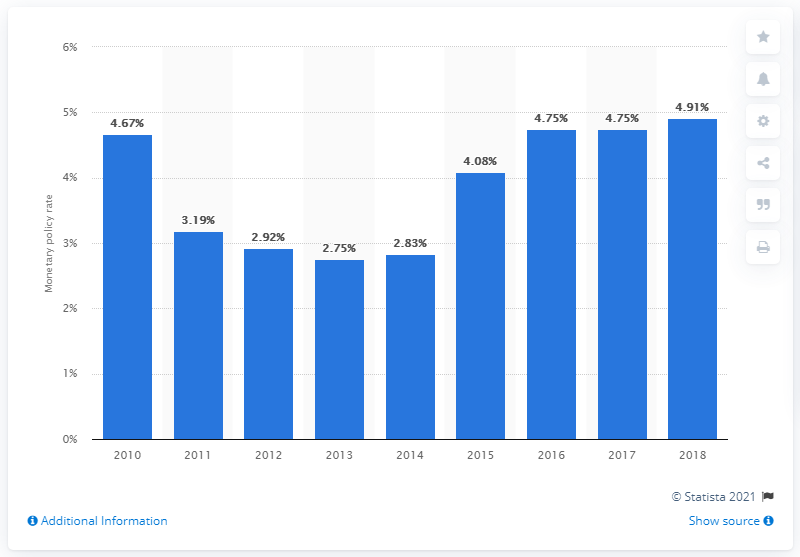Identify some key points in this picture. In 2013, the monetary policy rate was 2.75%. The monetary policy rate in 2018 was 4.91%. 